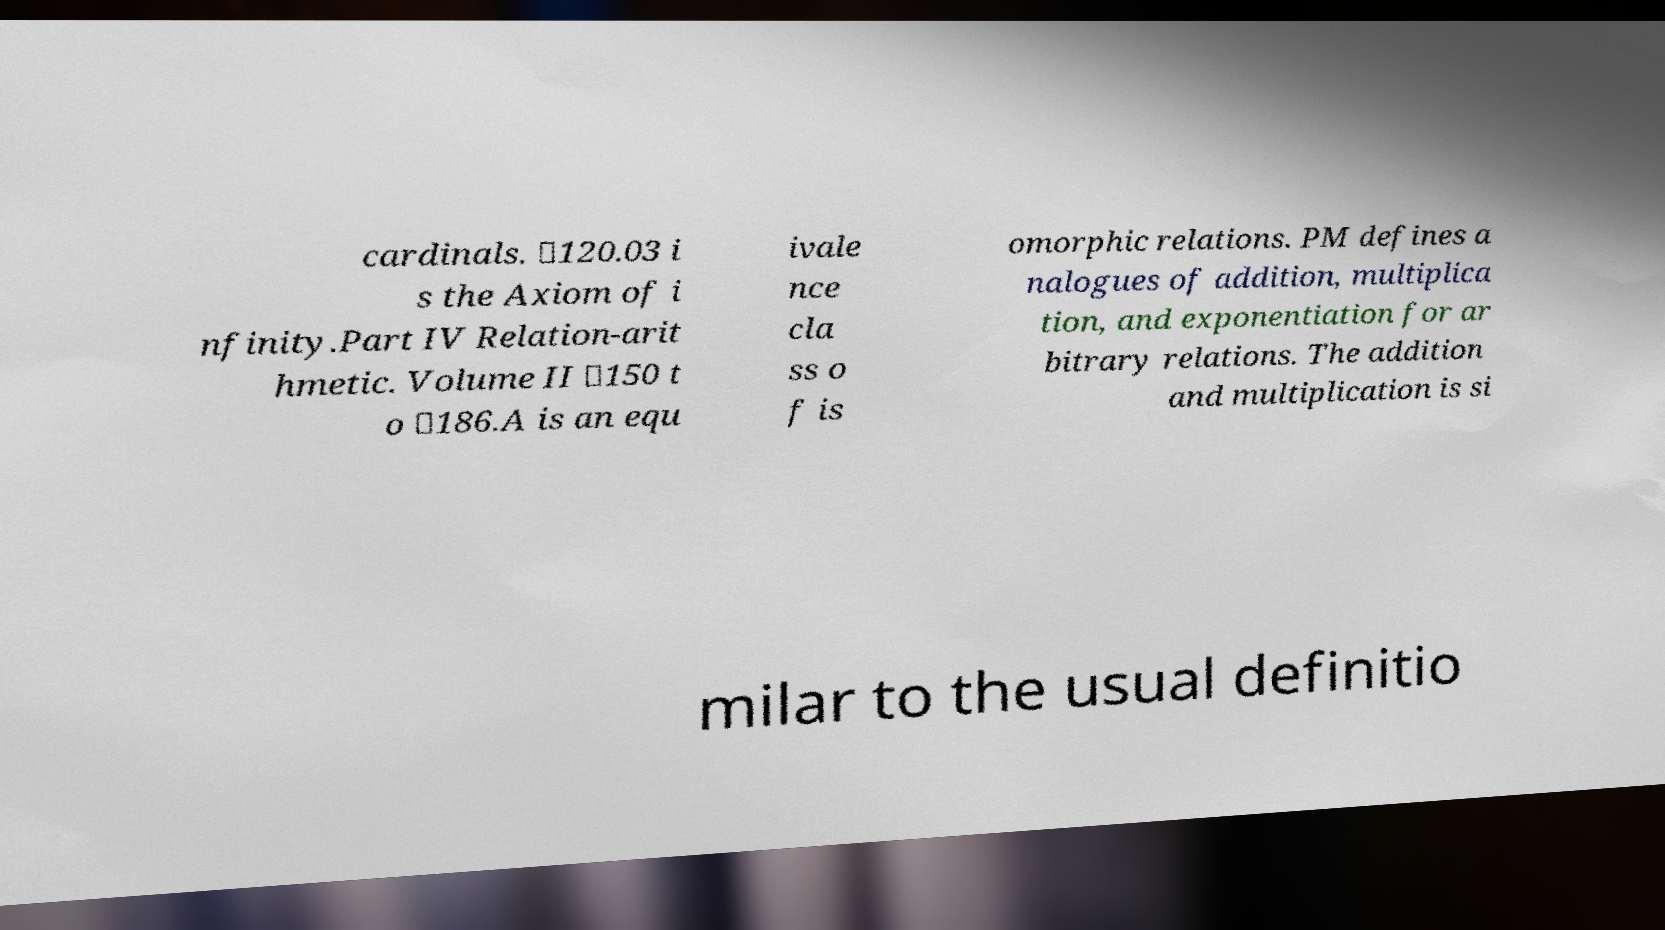What messages or text are displayed in this image? I need them in a readable, typed format. cardinals. ✸120.03 i s the Axiom of i nfinity.Part IV Relation-arit hmetic. Volume II ✸150 t o ✸186.A is an equ ivale nce cla ss o f is omorphic relations. PM defines a nalogues of addition, multiplica tion, and exponentiation for ar bitrary relations. The addition and multiplication is si milar to the usual definitio 